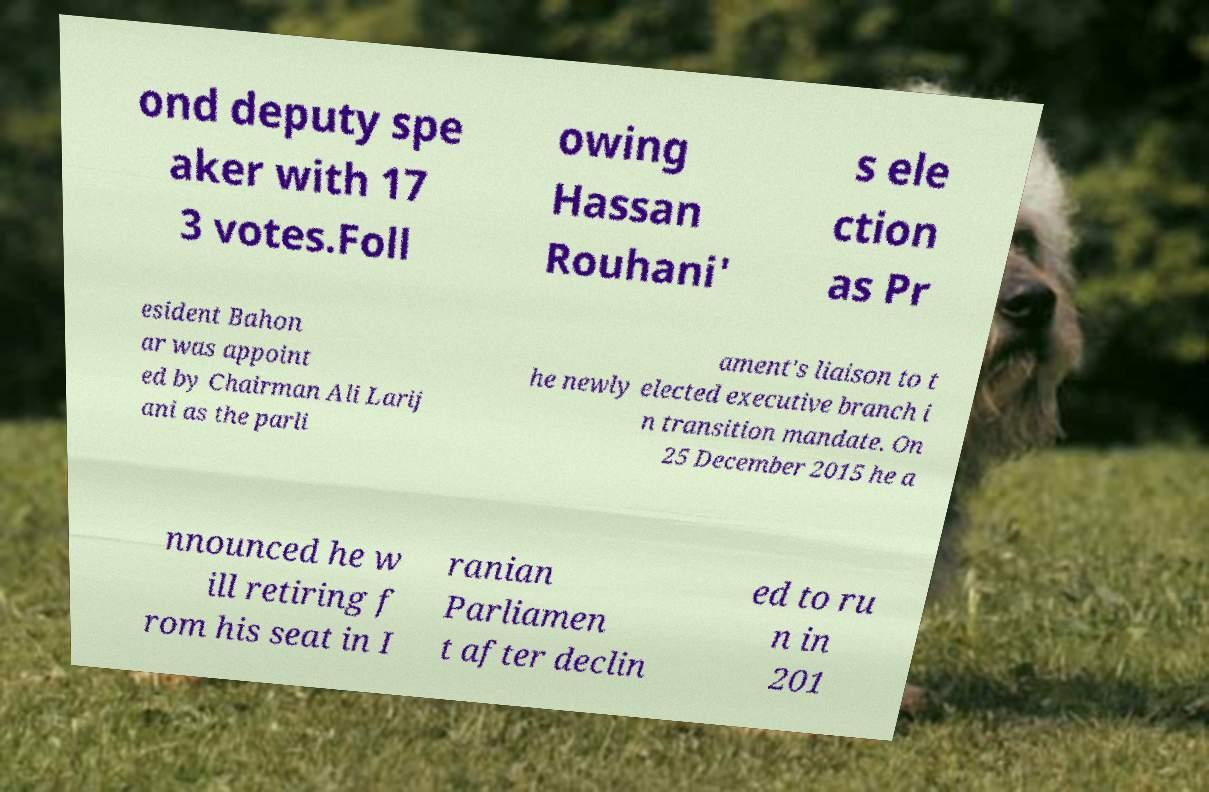Can you read and provide the text displayed in the image?This photo seems to have some interesting text. Can you extract and type it out for me? ond deputy spe aker with 17 3 votes.Foll owing Hassan Rouhani' s ele ction as Pr esident Bahon ar was appoint ed by Chairman Ali Larij ani as the parli ament's liaison to t he newly elected executive branch i n transition mandate. On 25 December 2015 he a nnounced he w ill retiring f rom his seat in I ranian Parliamen t after declin ed to ru n in 201 